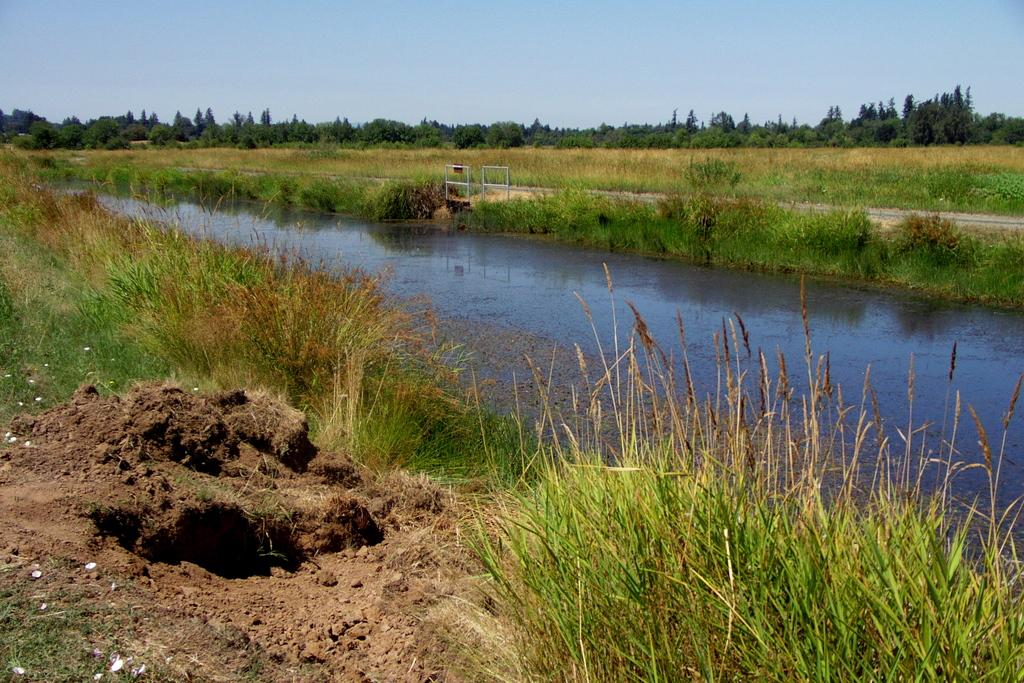What is the primary element visible in the image? There is water in the image. What type of vegetation is present on either side of the water? There is grass on either side of the water. What can be seen in the background of the image? There is a path, poles, trees, and the sky visible in the background of the image. How many bananas are hanging from the poles in the image? There are no bananas present in the image; the poles are not associated with any fruit. 